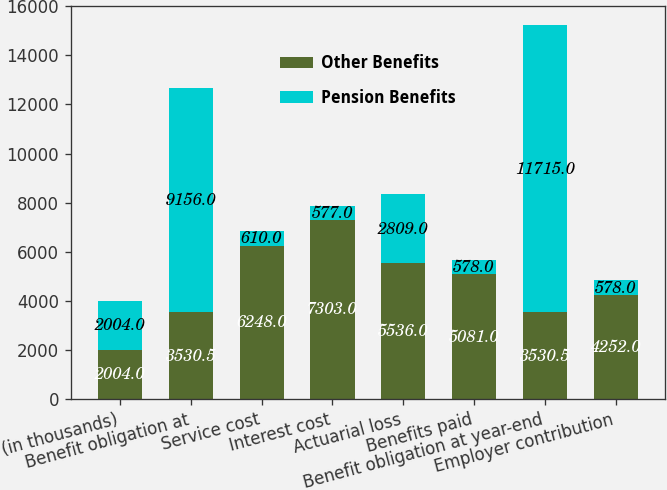<chart> <loc_0><loc_0><loc_500><loc_500><stacked_bar_chart><ecel><fcel>(in thousands)<fcel>Benefit obligation at<fcel>Service cost<fcel>Interest cost<fcel>Actuarial loss<fcel>Benefits paid<fcel>Benefit obligation at year-end<fcel>Employer contribution<nl><fcel>Other Benefits<fcel>2004<fcel>3530.5<fcel>6248<fcel>7303<fcel>5536<fcel>5081<fcel>3530.5<fcel>4252<nl><fcel>Pension Benefits<fcel>2004<fcel>9156<fcel>610<fcel>577<fcel>2809<fcel>578<fcel>11715<fcel>578<nl></chart> 